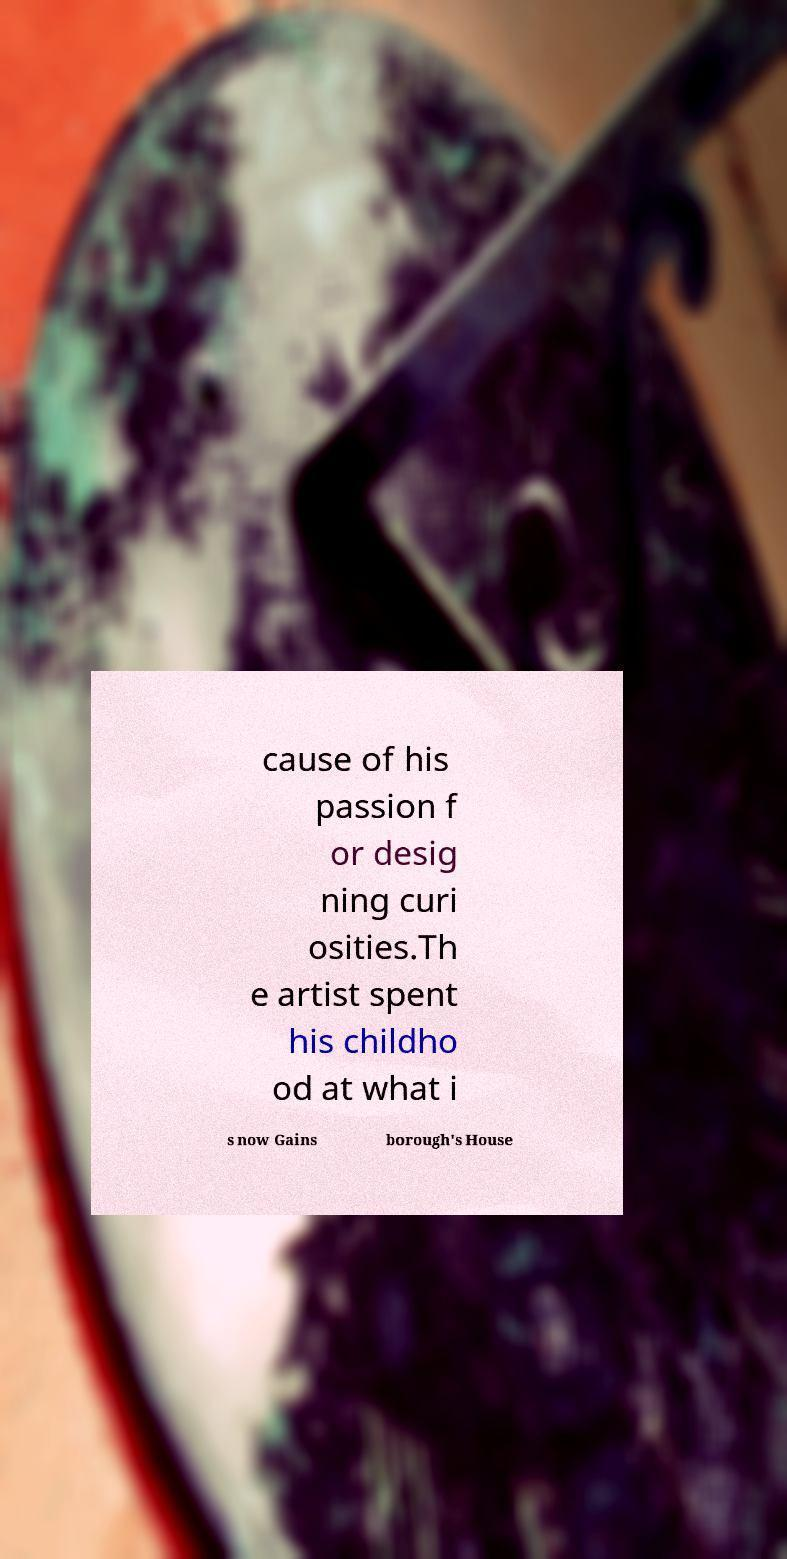There's text embedded in this image that I need extracted. Can you transcribe it verbatim? cause of his passion f or desig ning curi osities.Th e artist spent his childho od at what i s now Gains borough's House 